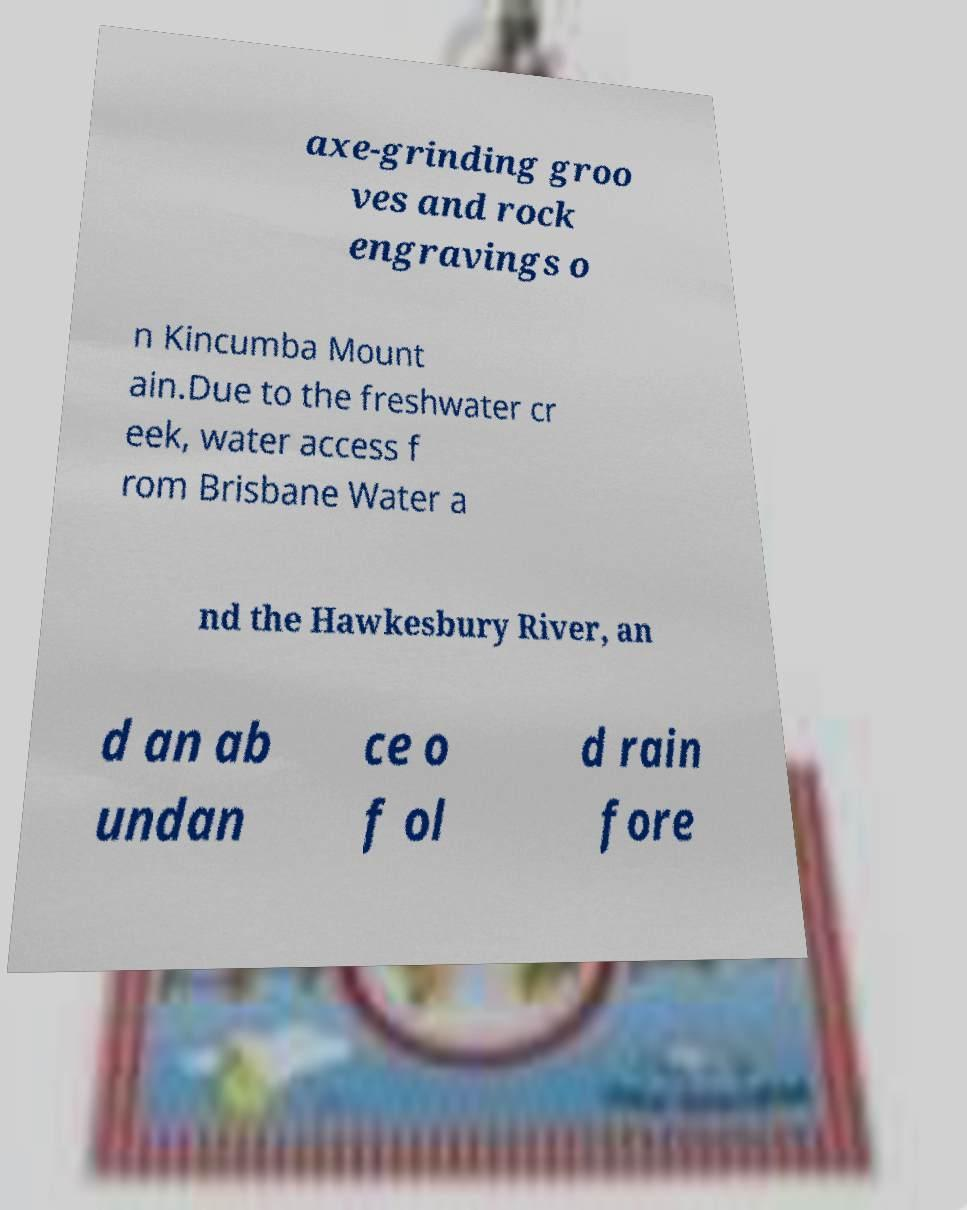What messages or text are displayed in this image? I need them in a readable, typed format. axe-grinding groo ves and rock engravings o n Kincumba Mount ain.Due to the freshwater cr eek, water access f rom Brisbane Water a nd the Hawkesbury River, an d an ab undan ce o f ol d rain fore 